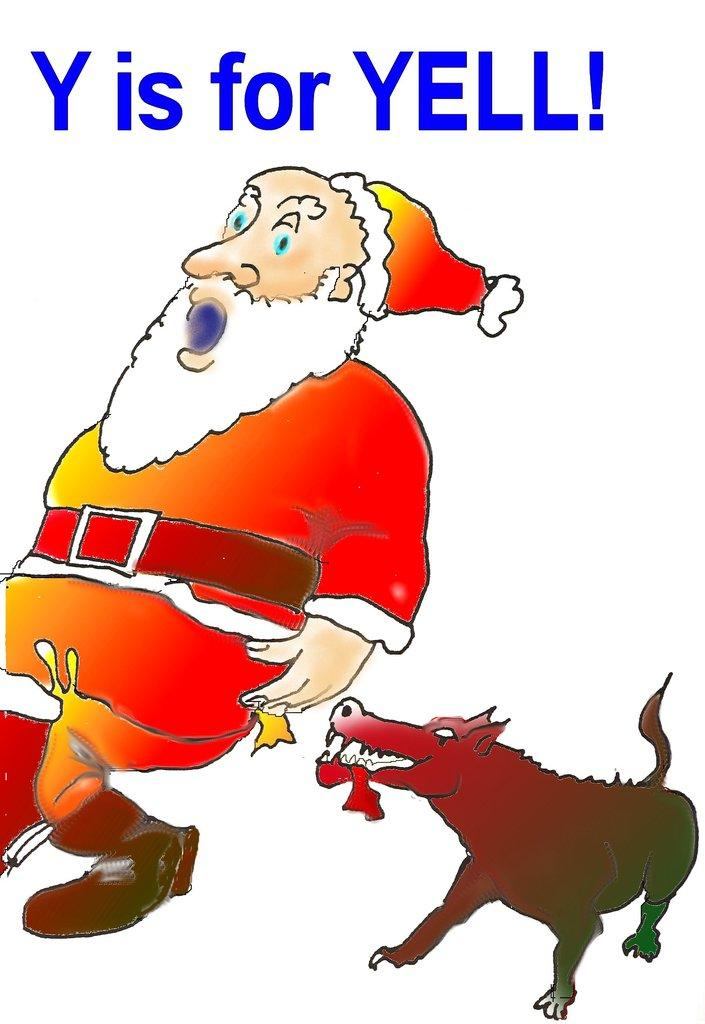What is the main subject of the image? The main subject of the image is an animated photo of Santa Claus. What is Santa Claus wearing in the image? Santa Claus is wearing a red dress in the image. Can you describe any other characters or objects in the image? There is a dog behind Santa Claus in the image. What text is written above Santa Claus in the image? The text "Y is for Yell" is written above Santa Claus in the image. What type of baseball play is depicted in the image? There is no baseball play depicted in the image; it features an animated photo of Santa Claus with a dog and the text "Y is for Yell." Can you identify the type of plane in the image? There is no plane present in the image. 